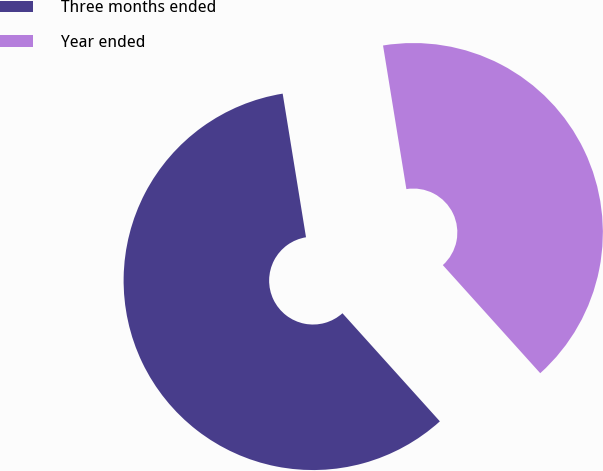Convert chart. <chart><loc_0><loc_0><loc_500><loc_500><pie_chart><fcel>Three months ended<fcel>Year ended<nl><fcel>59.11%<fcel>40.89%<nl></chart> 